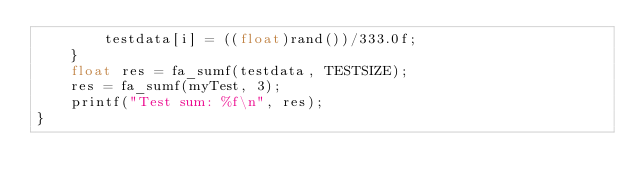Convert code to text. <code><loc_0><loc_0><loc_500><loc_500><_C_>		testdata[i] = ((float)rand())/333.0f;
	}
	float res = fa_sumf(testdata, TESTSIZE);
	res = fa_sumf(myTest, 3);
	printf("Test sum: %f\n", res);
}
</code> 